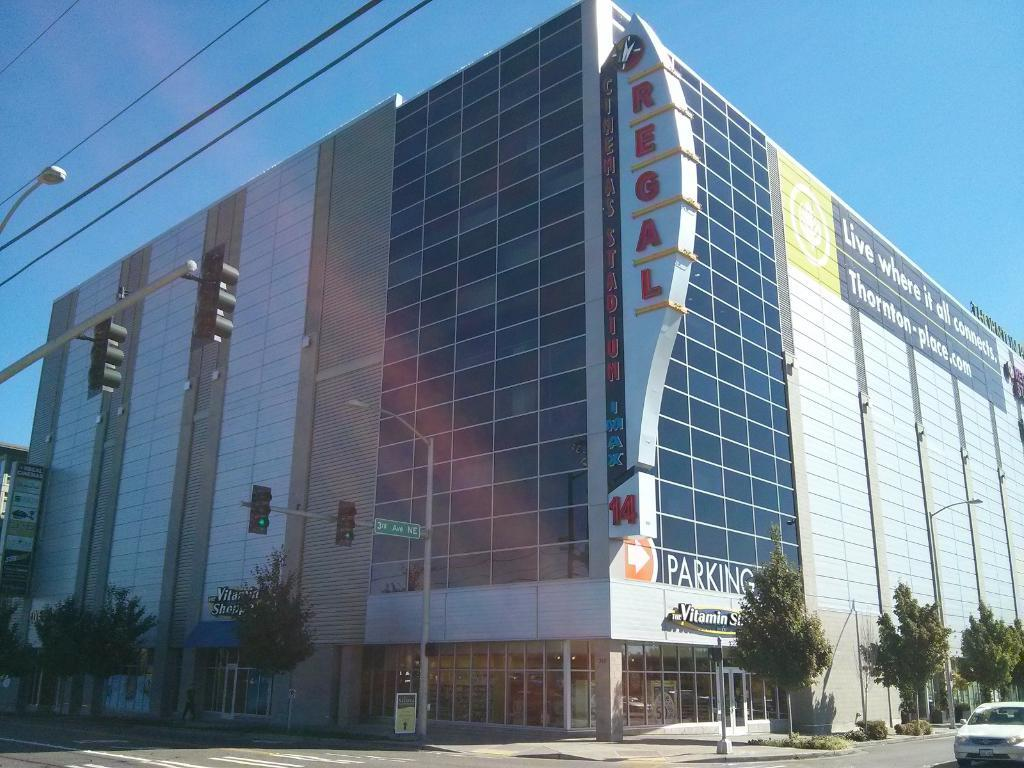What type of structure can be seen in the image? There is a building in the image. What natural elements are present in the image? There are trees and shrubs in the image. What man-made elements can be seen in the image? There is a traffic signal, light poles, wires, a hoarding, and a vehicle in the image. What is the vehicle doing in the image? The vehicle is passing on the road in the image. What part of the natural environment is visible in the image? The sky is visible in the image. Can you see any ants crawling on the building in the image? There are no ants visible in the image. What is the vehicle's reaction to the fear of heights in the image? There is no indication of fear in the image, and the vehicle is simply passing on the road. Is there a giraffe visible in the image? There are no giraffes present in the image. 